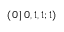<formula> <loc_0><loc_0><loc_500><loc_500>( 0 \, | \, 0 , 1 , 1 ; 1 )</formula> 